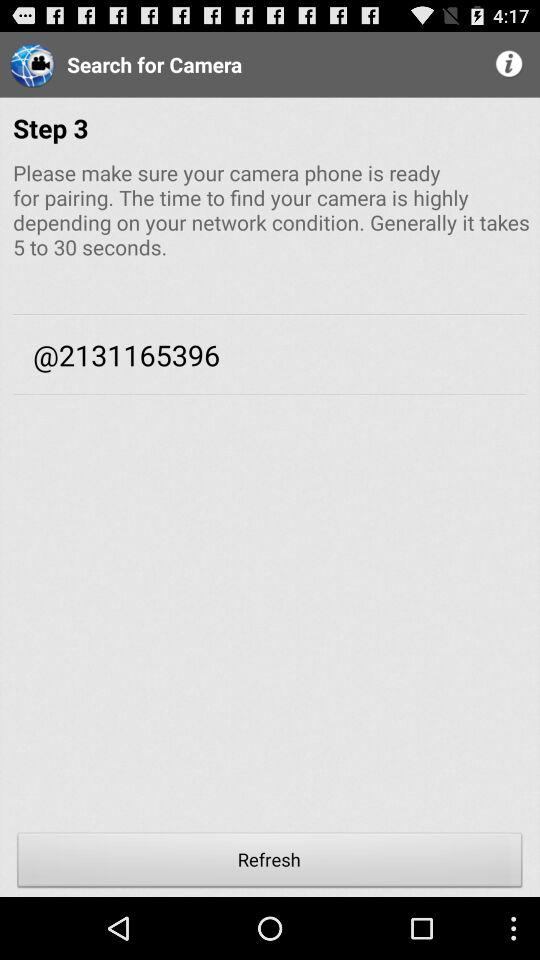What number is shown on the screen? The number shown on the screen is 2131165396. 